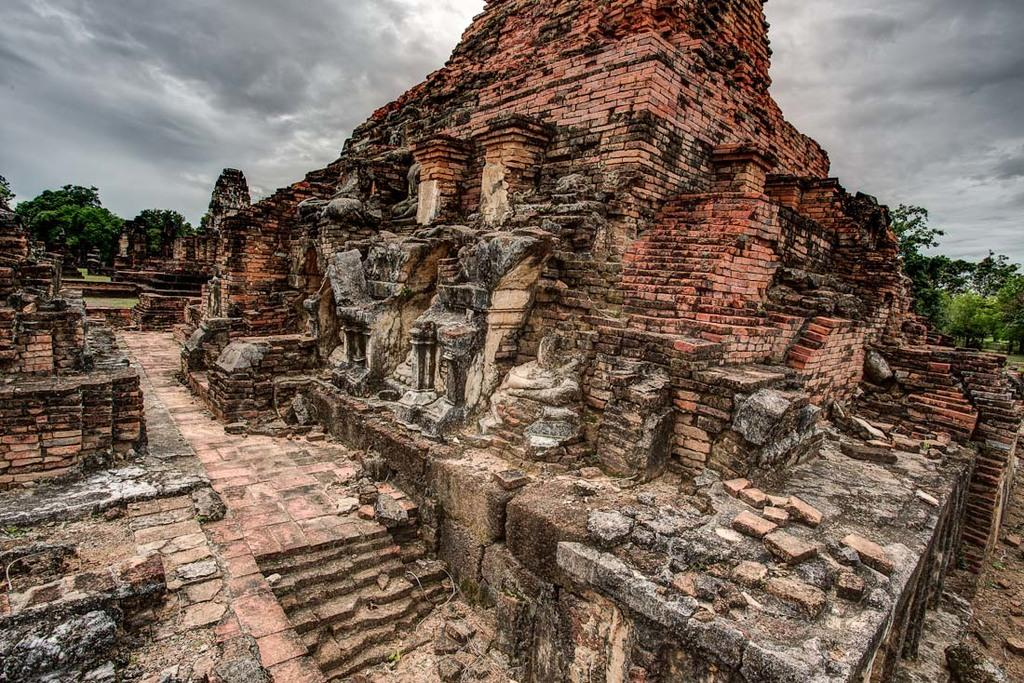What type of structure is shown in the image? The image depicts an historical temple. What can be seen in the foreground of the image? There are trees in the image. What is visible in the background of the image? The sky is visible in the background of the image. What type of vest is being worn by the corn in the image? There is no corn or vest present in the image. 